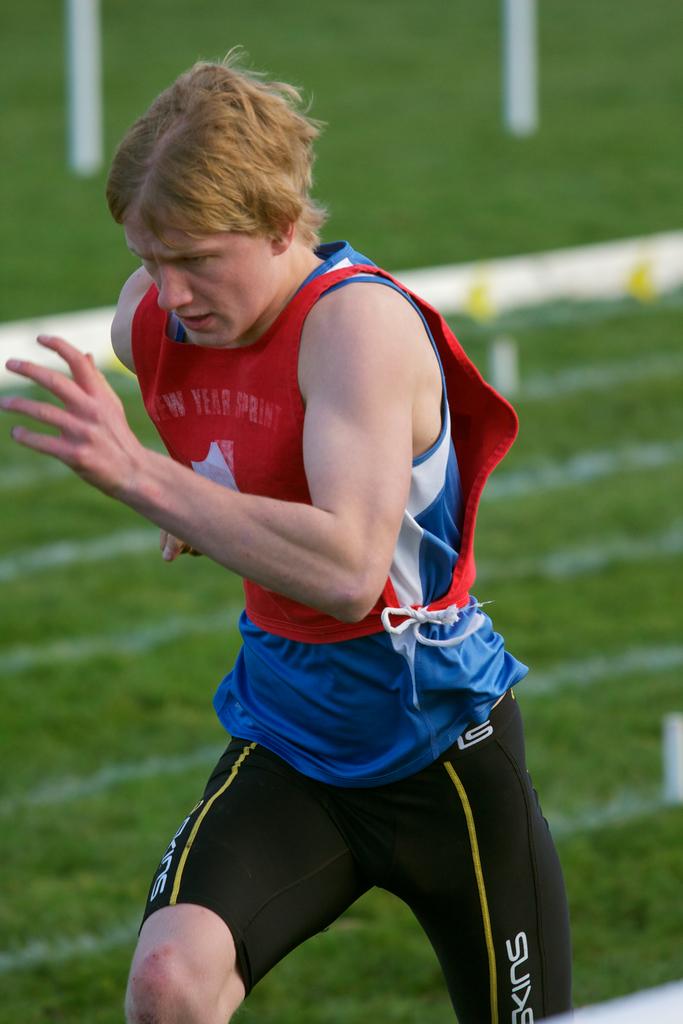What organization is the runner a part of?
Your answer should be very brief. Unanswerable. 